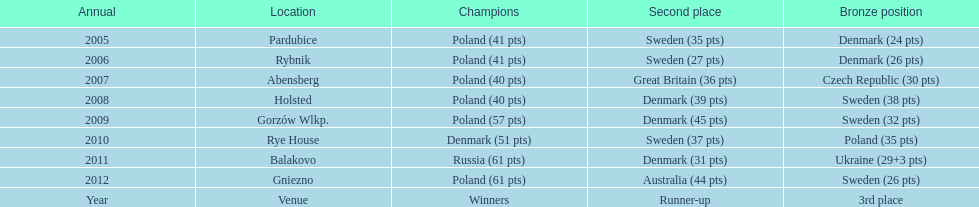From 2005-2012, in the team speedway junior world championship, how many more first place wins than all other teams put together? Poland. 